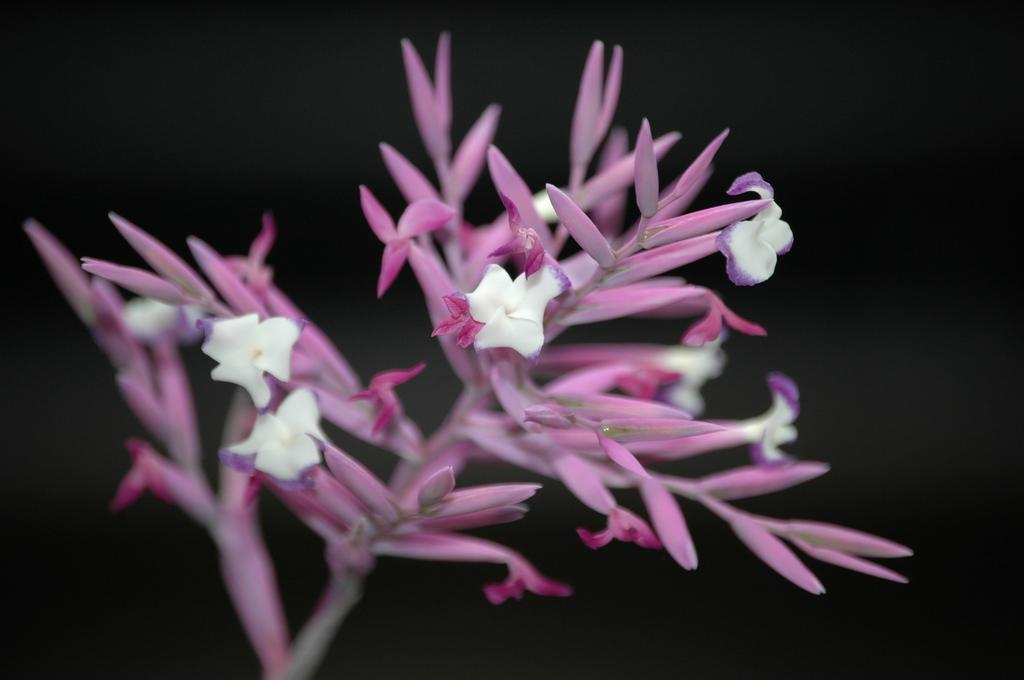What type of living organisms can be seen in the image? There are flowers and a plant visible in the image. Can you describe the plant in the image? Unfortunately, the provided facts do not give enough information to describe the plant in detail. How many flowers are present in the image? The number of flowers in the image cannot be determined from the provided facts. What type of bubble can be seen floating near the flowers in the image? There is no bubble present in the image; it only features flowers and a plant. How does the beggar interact with the flowers in the image? There is no beggar present in the image; it only features flowers and a plant. 